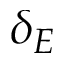Convert formula to latex. <formula><loc_0><loc_0><loc_500><loc_500>\delta _ { E }</formula> 